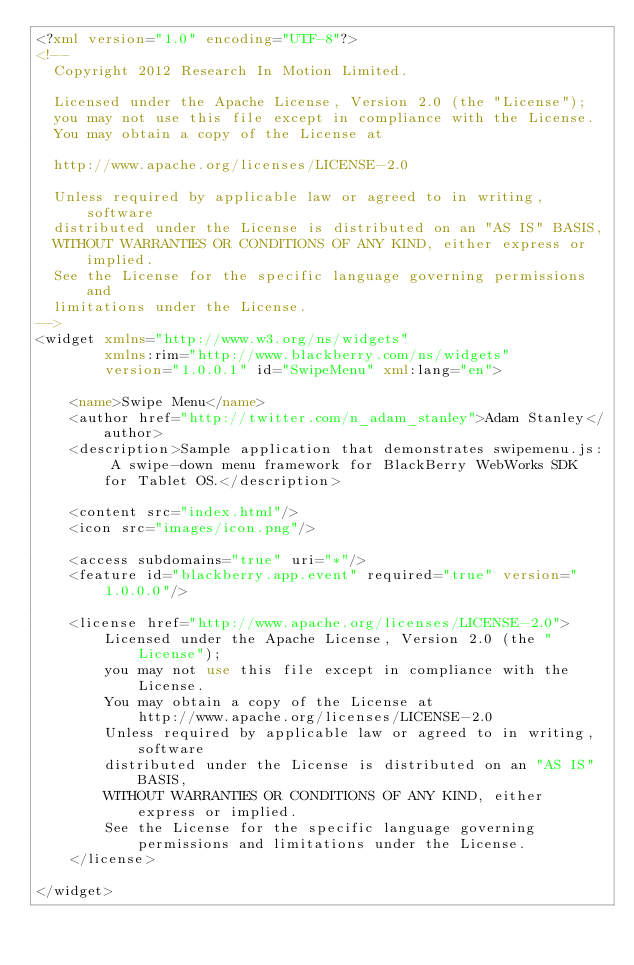<code> <loc_0><loc_0><loc_500><loc_500><_XML_><?xml version="1.0" encoding="UTF-8"?>
<!--
  Copyright 2012 Research In Motion Limited.

  Licensed under the Apache License, Version 2.0 (the "License");
  you may not use this file except in compliance with the License.
  You may obtain a copy of the License at

  http://www.apache.org/licenses/LICENSE-2.0

  Unless required by applicable law or agreed to in writing, software
  distributed under the License is distributed on an "AS IS" BASIS,
  WITHOUT WARRANTIES OR CONDITIONS OF ANY KIND, either express or implied.
  See the License for the specific language governing permissions and
  limitations under the License.
-->
<widget xmlns="http://www.w3.org/ns/widgets"
        xmlns:rim="http://www.blackberry.com/ns/widgets"
        version="1.0.0.1" id="SwipeMenu" xml:lang="en">

	<name>Swipe Menu</name>
	<author href="http://twitter.com/n_adam_stanley">Adam Stanley</author>
	<description>Sample application that demonstrates swipemenu.js: A swipe-down menu framework for BlackBerry WebWorks SDK for Tablet OS.</description>

	<content src="index.html"/>
	<icon src="images/icon.png"/>

	<access subdomains="true" uri="*"/>
	<feature id="blackberry.app.event" required="true" version="1.0.0.0"/>

	<license href="http://www.apache.org/licenses/LICENSE-2.0">
		Licensed under the Apache License, Version 2.0 (the "License");
		you may not use this file except in compliance with the License.
		You may obtain a copy of the License at
			http://www.apache.org/licenses/LICENSE-2.0
		Unless required by applicable law or agreed to in writing, software
		distributed under the License is distributed on an "AS IS" BASIS,
		WITHOUT WARRANTIES OR CONDITIONS OF ANY KIND, either express or implied.
		See the License for the specific language governing permissions and limitations under the License.
	</license>

</widget></code> 